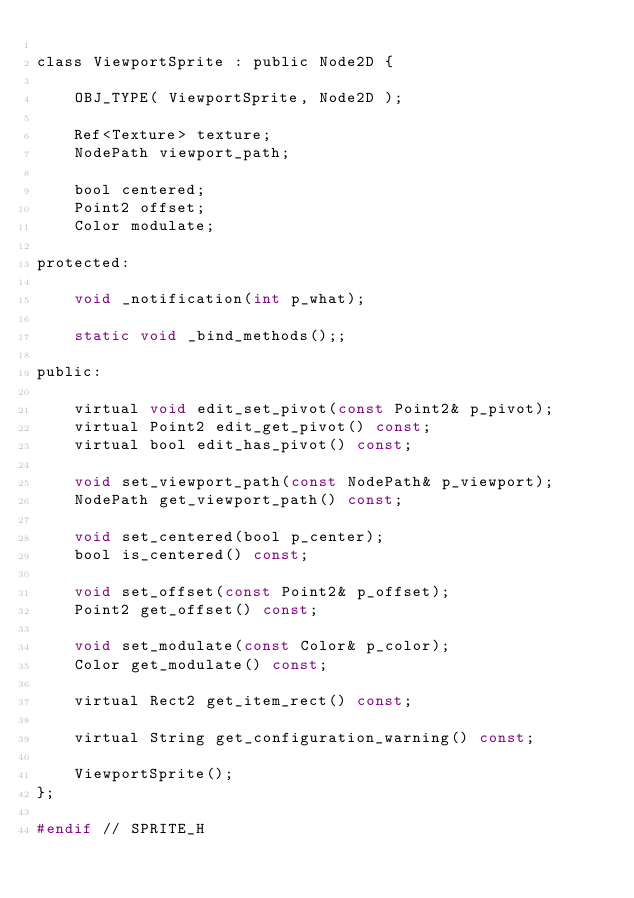Convert code to text. <code><loc_0><loc_0><loc_500><loc_500><_C_>
class ViewportSprite : public Node2D {

	OBJ_TYPE( ViewportSprite, Node2D );

	Ref<Texture> texture;
	NodePath viewport_path;

	bool centered;
	Point2 offset;
	Color modulate;

protected:

	void _notification(int p_what);

	static void _bind_methods();;

public:

	virtual void edit_set_pivot(const Point2& p_pivot);
	virtual Point2 edit_get_pivot() const;
	virtual bool edit_has_pivot() const;

	void set_viewport_path(const NodePath& p_viewport);
	NodePath get_viewport_path() const;

	void set_centered(bool p_center);
	bool is_centered() const;

	void set_offset(const Point2& p_offset);
	Point2 get_offset() const;

	void set_modulate(const Color& p_color);
	Color get_modulate() const;

	virtual Rect2 get_item_rect() const;

	virtual String get_configuration_warning() const;

	ViewportSprite();
};

#endif // SPRITE_H
</code> 